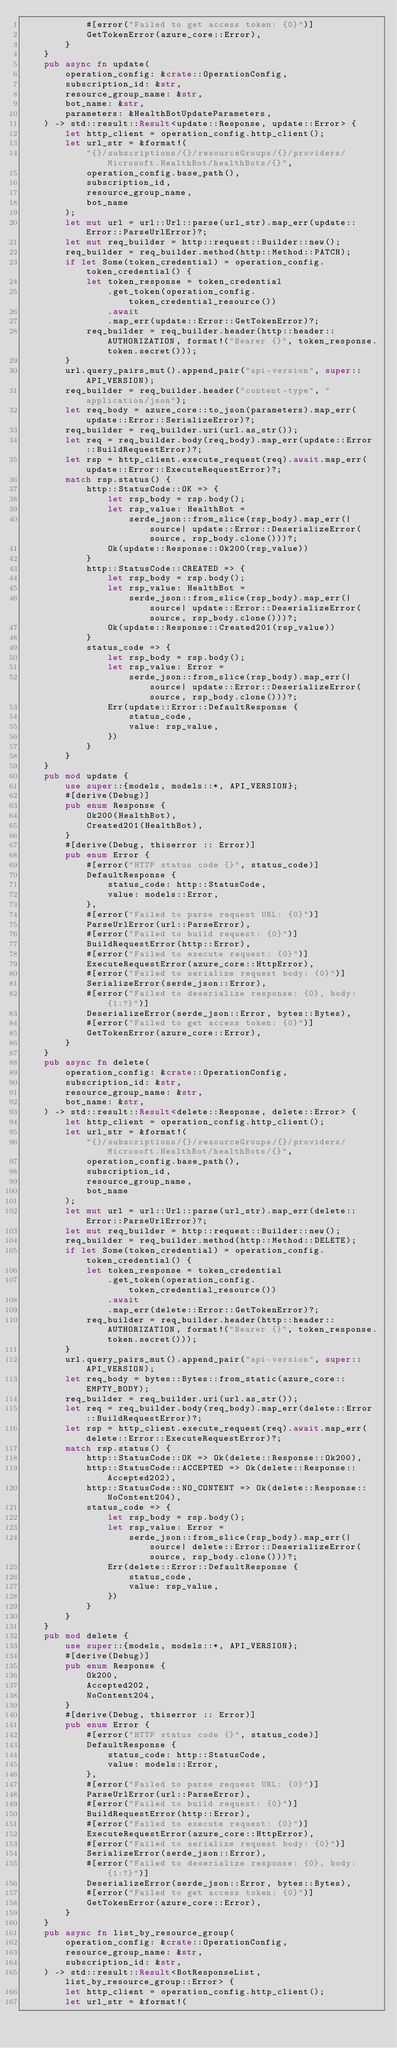Convert code to text. <code><loc_0><loc_0><loc_500><loc_500><_Rust_>            #[error("Failed to get access token: {0}")]
            GetTokenError(azure_core::Error),
        }
    }
    pub async fn update(
        operation_config: &crate::OperationConfig,
        subscription_id: &str,
        resource_group_name: &str,
        bot_name: &str,
        parameters: &HealthBotUpdateParameters,
    ) -> std::result::Result<update::Response, update::Error> {
        let http_client = operation_config.http_client();
        let url_str = &format!(
            "{}/subscriptions/{}/resourceGroups/{}/providers/Microsoft.HealthBot/healthBots/{}",
            operation_config.base_path(),
            subscription_id,
            resource_group_name,
            bot_name
        );
        let mut url = url::Url::parse(url_str).map_err(update::Error::ParseUrlError)?;
        let mut req_builder = http::request::Builder::new();
        req_builder = req_builder.method(http::Method::PATCH);
        if let Some(token_credential) = operation_config.token_credential() {
            let token_response = token_credential
                .get_token(operation_config.token_credential_resource())
                .await
                .map_err(update::Error::GetTokenError)?;
            req_builder = req_builder.header(http::header::AUTHORIZATION, format!("Bearer {}", token_response.token.secret()));
        }
        url.query_pairs_mut().append_pair("api-version", super::API_VERSION);
        req_builder = req_builder.header("content-type", "application/json");
        let req_body = azure_core::to_json(parameters).map_err(update::Error::SerializeError)?;
        req_builder = req_builder.uri(url.as_str());
        let req = req_builder.body(req_body).map_err(update::Error::BuildRequestError)?;
        let rsp = http_client.execute_request(req).await.map_err(update::Error::ExecuteRequestError)?;
        match rsp.status() {
            http::StatusCode::OK => {
                let rsp_body = rsp.body();
                let rsp_value: HealthBot =
                    serde_json::from_slice(rsp_body).map_err(|source| update::Error::DeserializeError(source, rsp_body.clone()))?;
                Ok(update::Response::Ok200(rsp_value))
            }
            http::StatusCode::CREATED => {
                let rsp_body = rsp.body();
                let rsp_value: HealthBot =
                    serde_json::from_slice(rsp_body).map_err(|source| update::Error::DeserializeError(source, rsp_body.clone()))?;
                Ok(update::Response::Created201(rsp_value))
            }
            status_code => {
                let rsp_body = rsp.body();
                let rsp_value: Error =
                    serde_json::from_slice(rsp_body).map_err(|source| update::Error::DeserializeError(source, rsp_body.clone()))?;
                Err(update::Error::DefaultResponse {
                    status_code,
                    value: rsp_value,
                })
            }
        }
    }
    pub mod update {
        use super::{models, models::*, API_VERSION};
        #[derive(Debug)]
        pub enum Response {
            Ok200(HealthBot),
            Created201(HealthBot),
        }
        #[derive(Debug, thiserror :: Error)]
        pub enum Error {
            #[error("HTTP status code {}", status_code)]
            DefaultResponse {
                status_code: http::StatusCode,
                value: models::Error,
            },
            #[error("Failed to parse request URL: {0}")]
            ParseUrlError(url::ParseError),
            #[error("Failed to build request: {0}")]
            BuildRequestError(http::Error),
            #[error("Failed to execute request: {0}")]
            ExecuteRequestError(azure_core::HttpError),
            #[error("Failed to serialize request body: {0}")]
            SerializeError(serde_json::Error),
            #[error("Failed to deserialize response: {0}, body: {1:?}")]
            DeserializeError(serde_json::Error, bytes::Bytes),
            #[error("Failed to get access token: {0}")]
            GetTokenError(azure_core::Error),
        }
    }
    pub async fn delete(
        operation_config: &crate::OperationConfig,
        subscription_id: &str,
        resource_group_name: &str,
        bot_name: &str,
    ) -> std::result::Result<delete::Response, delete::Error> {
        let http_client = operation_config.http_client();
        let url_str = &format!(
            "{}/subscriptions/{}/resourceGroups/{}/providers/Microsoft.HealthBot/healthBots/{}",
            operation_config.base_path(),
            subscription_id,
            resource_group_name,
            bot_name
        );
        let mut url = url::Url::parse(url_str).map_err(delete::Error::ParseUrlError)?;
        let mut req_builder = http::request::Builder::new();
        req_builder = req_builder.method(http::Method::DELETE);
        if let Some(token_credential) = operation_config.token_credential() {
            let token_response = token_credential
                .get_token(operation_config.token_credential_resource())
                .await
                .map_err(delete::Error::GetTokenError)?;
            req_builder = req_builder.header(http::header::AUTHORIZATION, format!("Bearer {}", token_response.token.secret()));
        }
        url.query_pairs_mut().append_pair("api-version", super::API_VERSION);
        let req_body = bytes::Bytes::from_static(azure_core::EMPTY_BODY);
        req_builder = req_builder.uri(url.as_str());
        let req = req_builder.body(req_body).map_err(delete::Error::BuildRequestError)?;
        let rsp = http_client.execute_request(req).await.map_err(delete::Error::ExecuteRequestError)?;
        match rsp.status() {
            http::StatusCode::OK => Ok(delete::Response::Ok200),
            http::StatusCode::ACCEPTED => Ok(delete::Response::Accepted202),
            http::StatusCode::NO_CONTENT => Ok(delete::Response::NoContent204),
            status_code => {
                let rsp_body = rsp.body();
                let rsp_value: Error =
                    serde_json::from_slice(rsp_body).map_err(|source| delete::Error::DeserializeError(source, rsp_body.clone()))?;
                Err(delete::Error::DefaultResponse {
                    status_code,
                    value: rsp_value,
                })
            }
        }
    }
    pub mod delete {
        use super::{models, models::*, API_VERSION};
        #[derive(Debug)]
        pub enum Response {
            Ok200,
            Accepted202,
            NoContent204,
        }
        #[derive(Debug, thiserror :: Error)]
        pub enum Error {
            #[error("HTTP status code {}", status_code)]
            DefaultResponse {
                status_code: http::StatusCode,
                value: models::Error,
            },
            #[error("Failed to parse request URL: {0}")]
            ParseUrlError(url::ParseError),
            #[error("Failed to build request: {0}")]
            BuildRequestError(http::Error),
            #[error("Failed to execute request: {0}")]
            ExecuteRequestError(azure_core::HttpError),
            #[error("Failed to serialize request body: {0}")]
            SerializeError(serde_json::Error),
            #[error("Failed to deserialize response: {0}, body: {1:?}")]
            DeserializeError(serde_json::Error, bytes::Bytes),
            #[error("Failed to get access token: {0}")]
            GetTokenError(azure_core::Error),
        }
    }
    pub async fn list_by_resource_group(
        operation_config: &crate::OperationConfig,
        resource_group_name: &str,
        subscription_id: &str,
    ) -> std::result::Result<BotResponseList, list_by_resource_group::Error> {
        let http_client = operation_config.http_client();
        let url_str = &format!(</code> 